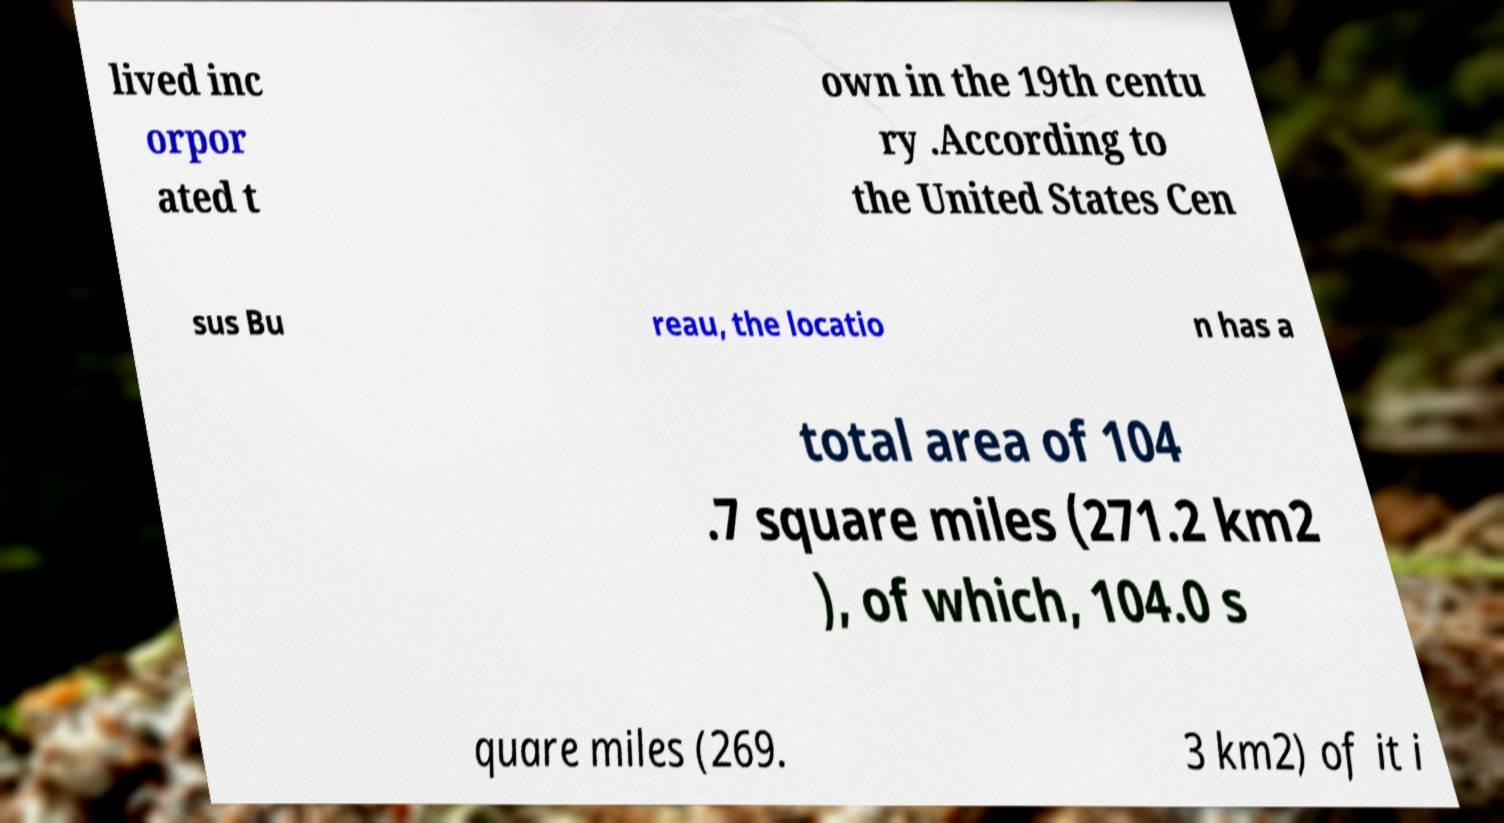What messages or text are displayed in this image? I need them in a readable, typed format. lived inc orpor ated t own in the 19th centu ry .According to the United States Cen sus Bu reau, the locatio n has a total area of 104 .7 square miles (271.2 km2 ), of which, 104.0 s quare miles (269. 3 km2) of it i 